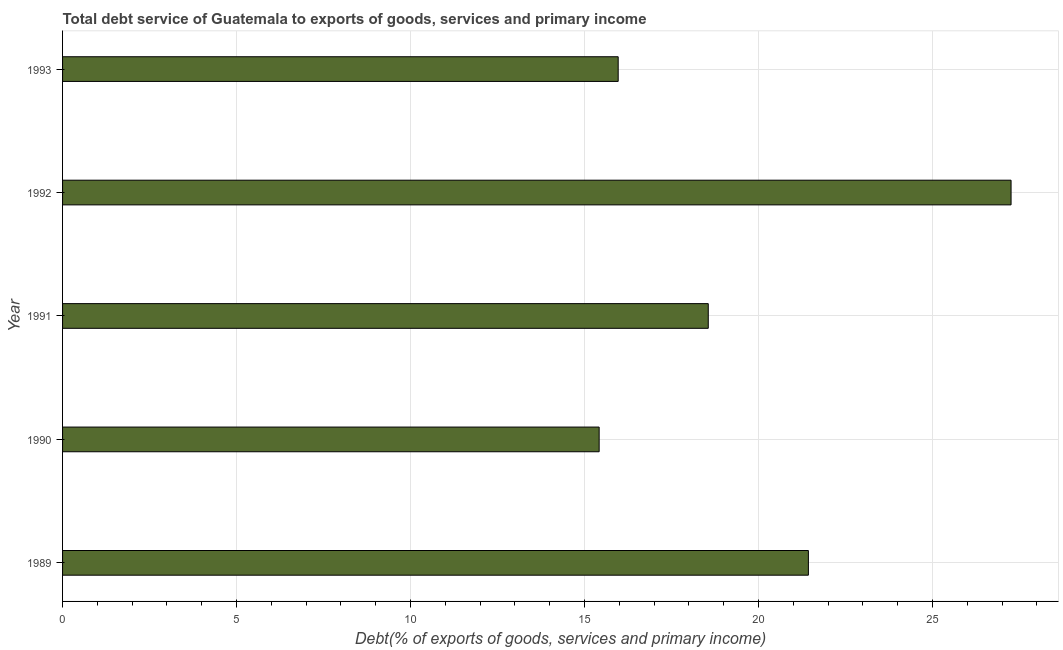What is the title of the graph?
Your answer should be very brief. Total debt service of Guatemala to exports of goods, services and primary income. What is the label or title of the X-axis?
Your answer should be very brief. Debt(% of exports of goods, services and primary income). What is the label or title of the Y-axis?
Your response must be concise. Year. What is the total debt service in 1990?
Provide a short and direct response. 15.42. Across all years, what is the maximum total debt service?
Ensure brevity in your answer.  27.26. Across all years, what is the minimum total debt service?
Give a very brief answer. 15.42. In which year was the total debt service maximum?
Your response must be concise. 1992. What is the sum of the total debt service?
Your answer should be compact. 98.63. What is the difference between the total debt service in 1989 and 1992?
Keep it short and to the point. -5.82. What is the average total debt service per year?
Your answer should be very brief. 19.73. What is the median total debt service?
Give a very brief answer. 18.56. Do a majority of the years between 1990 and 1989 (inclusive) have total debt service greater than 18 %?
Provide a succinct answer. No. What is the ratio of the total debt service in 1990 to that in 1991?
Make the answer very short. 0.83. Is the total debt service in 1989 less than that in 1990?
Ensure brevity in your answer.  No. What is the difference between the highest and the second highest total debt service?
Provide a short and direct response. 5.82. What is the difference between the highest and the lowest total debt service?
Give a very brief answer. 11.84. In how many years, is the total debt service greater than the average total debt service taken over all years?
Your response must be concise. 2. How many bars are there?
Your answer should be very brief. 5. Are all the bars in the graph horizontal?
Provide a succinct answer. Yes. Are the values on the major ticks of X-axis written in scientific E-notation?
Offer a terse response. No. What is the Debt(% of exports of goods, services and primary income) of 1989?
Offer a terse response. 21.43. What is the Debt(% of exports of goods, services and primary income) in 1990?
Provide a succinct answer. 15.42. What is the Debt(% of exports of goods, services and primary income) in 1991?
Give a very brief answer. 18.56. What is the Debt(% of exports of goods, services and primary income) in 1992?
Offer a very short reply. 27.26. What is the Debt(% of exports of goods, services and primary income) of 1993?
Your answer should be very brief. 15.97. What is the difference between the Debt(% of exports of goods, services and primary income) in 1989 and 1990?
Ensure brevity in your answer.  6.01. What is the difference between the Debt(% of exports of goods, services and primary income) in 1989 and 1991?
Make the answer very short. 2.88. What is the difference between the Debt(% of exports of goods, services and primary income) in 1989 and 1992?
Make the answer very short. -5.82. What is the difference between the Debt(% of exports of goods, services and primary income) in 1989 and 1993?
Make the answer very short. 5.47. What is the difference between the Debt(% of exports of goods, services and primary income) in 1990 and 1991?
Give a very brief answer. -3.14. What is the difference between the Debt(% of exports of goods, services and primary income) in 1990 and 1992?
Your response must be concise. -11.84. What is the difference between the Debt(% of exports of goods, services and primary income) in 1990 and 1993?
Your answer should be compact. -0.55. What is the difference between the Debt(% of exports of goods, services and primary income) in 1991 and 1992?
Your answer should be very brief. -8.7. What is the difference between the Debt(% of exports of goods, services and primary income) in 1991 and 1993?
Ensure brevity in your answer.  2.59. What is the difference between the Debt(% of exports of goods, services and primary income) in 1992 and 1993?
Provide a succinct answer. 11.29. What is the ratio of the Debt(% of exports of goods, services and primary income) in 1989 to that in 1990?
Your answer should be compact. 1.39. What is the ratio of the Debt(% of exports of goods, services and primary income) in 1989 to that in 1991?
Your answer should be compact. 1.16. What is the ratio of the Debt(% of exports of goods, services and primary income) in 1989 to that in 1992?
Your response must be concise. 0.79. What is the ratio of the Debt(% of exports of goods, services and primary income) in 1989 to that in 1993?
Provide a short and direct response. 1.34. What is the ratio of the Debt(% of exports of goods, services and primary income) in 1990 to that in 1991?
Provide a succinct answer. 0.83. What is the ratio of the Debt(% of exports of goods, services and primary income) in 1990 to that in 1992?
Make the answer very short. 0.57. What is the ratio of the Debt(% of exports of goods, services and primary income) in 1990 to that in 1993?
Give a very brief answer. 0.97. What is the ratio of the Debt(% of exports of goods, services and primary income) in 1991 to that in 1992?
Ensure brevity in your answer.  0.68. What is the ratio of the Debt(% of exports of goods, services and primary income) in 1991 to that in 1993?
Give a very brief answer. 1.16. What is the ratio of the Debt(% of exports of goods, services and primary income) in 1992 to that in 1993?
Offer a very short reply. 1.71. 